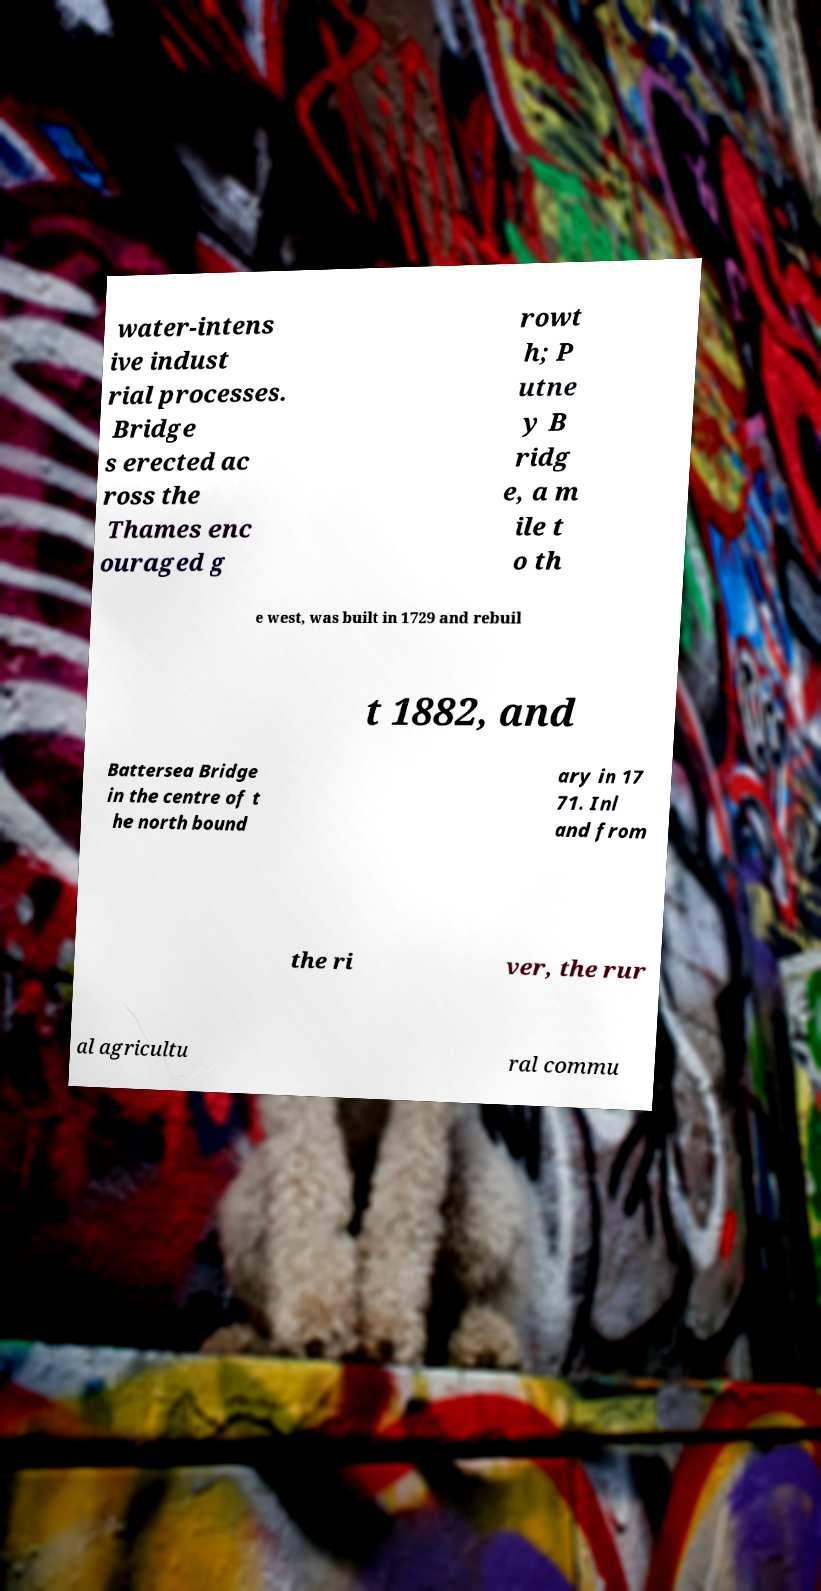Please identify and transcribe the text found in this image. water-intens ive indust rial processes. Bridge s erected ac ross the Thames enc ouraged g rowt h; P utne y B ridg e, a m ile t o th e west, was built in 1729 and rebuil t 1882, and Battersea Bridge in the centre of t he north bound ary in 17 71. Inl and from the ri ver, the rur al agricultu ral commu 